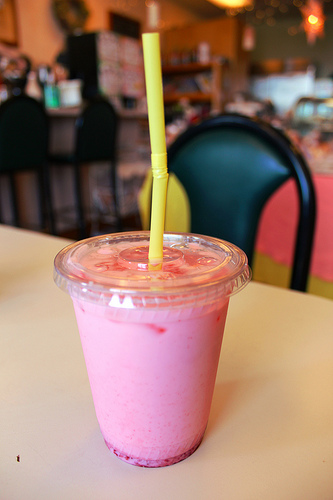<image>
Is there a milkshake on the table? Yes. Looking at the image, I can see the milkshake is positioned on top of the table, with the table providing support. Is the straw on the table? No. The straw is not positioned on the table. They may be near each other, but the straw is not supported by or resting on top of the table. 